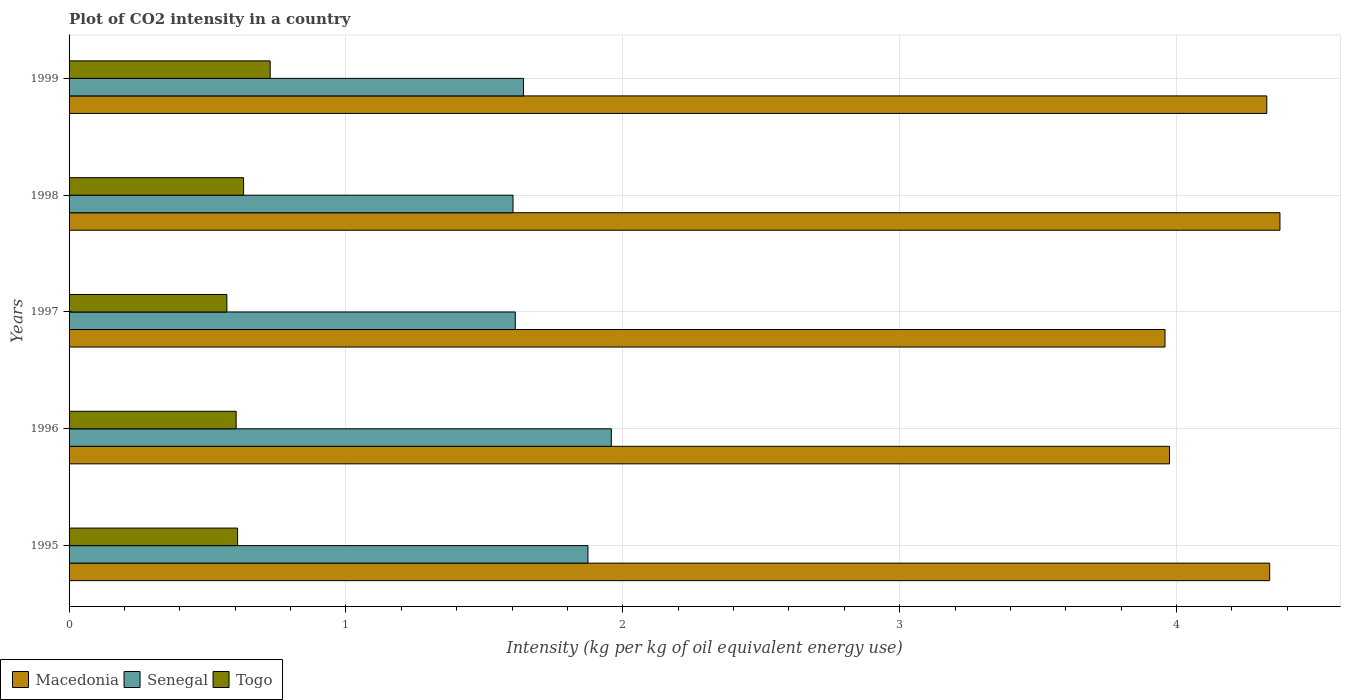How many different coloured bars are there?
Provide a succinct answer. 3. How many groups of bars are there?
Offer a terse response. 5. Are the number of bars per tick equal to the number of legend labels?
Your answer should be very brief. Yes. What is the CO2 intensity in in Senegal in 1998?
Your answer should be compact. 1.6. Across all years, what is the maximum CO2 intensity in in Togo?
Provide a short and direct response. 0.73. Across all years, what is the minimum CO2 intensity in in Togo?
Provide a succinct answer. 0.57. What is the total CO2 intensity in in Macedonia in the graph?
Your response must be concise. 20.97. What is the difference between the CO2 intensity in in Senegal in 1995 and that in 1999?
Your answer should be very brief. 0.23. What is the difference between the CO2 intensity in in Macedonia in 1997 and the CO2 intensity in in Togo in 1999?
Your response must be concise. 3.23. What is the average CO2 intensity in in Senegal per year?
Your answer should be very brief. 1.74. In the year 1996, what is the difference between the CO2 intensity in in Macedonia and CO2 intensity in in Senegal?
Your response must be concise. 2.02. What is the ratio of the CO2 intensity in in Senegal in 1995 to that in 1996?
Keep it short and to the point. 0.96. Is the difference between the CO2 intensity in in Macedonia in 1997 and 1999 greater than the difference between the CO2 intensity in in Senegal in 1997 and 1999?
Your response must be concise. No. What is the difference between the highest and the second highest CO2 intensity in in Macedonia?
Give a very brief answer. 0.04. What is the difference between the highest and the lowest CO2 intensity in in Togo?
Your response must be concise. 0.16. What does the 1st bar from the top in 1996 represents?
Ensure brevity in your answer.  Togo. What does the 1st bar from the bottom in 1998 represents?
Keep it short and to the point. Macedonia. Is it the case that in every year, the sum of the CO2 intensity in in Senegal and CO2 intensity in in Togo is greater than the CO2 intensity in in Macedonia?
Give a very brief answer. No. How many bars are there?
Your response must be concise. 15. Are all the bars in the graph horizontal?
Provide a short and direct response. Yes. Does the graph contain grids?
Ensure brevity in your answer.  Yes. Where does the legend appear in the graph?
Offer a terse response. Bottom left. How are the legend labels stacked?
Your answer should be very brief. Horizontal. What is the title of the graph?
Offer a terse response. Plot of CO2 intensity in a country. Does "Jordan" appear as one of the legend labels in the graph?
Provide a succinct answer. No. What is the label or title of the X-axis?
Offer a very short reply. Intensity (kg per kg of oil equivalent energy use). What is the label or title of the Y-axis?
Your response must be concise. Years. What is the Intensity (kg per kg of oil equivalent energy use) of Macedonia in 1995?
Offer a very short reply. 4.34. What is the Intensity (kg per kg of oil equivalent energy use) in Senegal in 1995?
Provide a short and direct response. 1.87. What is the Intensity (kg per kg of oil equivalent energy use) in Togo in 1995?
Offer a terse response. 0.61. What is the Intensity (kg per kg of oil equivalent energy use) in Macedonia in 1996?
Provide a short and direct response. 3.97. What is the Intensity (kg per kg of oil equivalent energy use) in Senegal in 1996?
Ensure brevity in your answer.  1.96. What is the Intensity (kg per kg of oil equivalent energy use) of Togo in 1996?
Your answer should be compact. 0.6. What is the Intensity (kg per kg of oil equivalent energy use) of Macedonia in 1997?
Provide a succinct answer. 3.96. What is the Intensity (kg per kg of oil equivalent energy use) in Senegal in 1997?
Your response must be concise. 1.61. What is the Intensity (kg per kg of oil equivalent energy use) in Togo in 1997?
Provide a short and direct response. 0.57. What is the Intensity (kg per kg of oil equivalent energy use) of Macedonia in 1998?
Your answer should be compact. 4.37. What is the Intensity (kg per kg of oil equivalent energy use) in Senegal in 1998?
Provide a succinct answer. 1.6. What is the Intensity (kg per kg of oil equivalent energy use) of Togo in 1998?
Offer a terse response. 0.63. What is the Intensity (kg per kg of oil equivalent energy use) of Macedonia in 1999?
Provide a short and direct response. 4.33. What is the Intensity (kg per kg of oil equivalent energy use) of Senegal in 1999?
Your answer should be compact. 1.64. What is the Intensity (kg per kg of oil equivalent energy use) in Togo in 1999?
Your answer should be very brief. 0.73. Across all years, what is the maximum Intensity (kg per kg of oil equivalent energy use) of Macedonia?
Make the answer very short. 4.37. Across all years, what is the maximum Intensity (kg per kg of oil equivalent energy use) in Senegal?
Your answer should be very brief. 1.96. Across all years, what is the maximum Intensity (kg per kg of oil equivalent energy use) of Togo?
Make the answer very short. 0.73. Across all years, what is the minimum Intensity (kg per kg of oil equivalent energy use) of Macedonia?
Provide a short and direct response. 3.96. Across all years, what is the minimum Intensity (kg per kg of oil equivalent energy use) of Senegal?
Your answer should be very brief. 1.6. Across all years, what is the minimum Intensity (kg per kg of oil equivalent energy use) of Togo?
Provide a short and direct response. 0.57. What is the total Intensity (kg per kg of oil equivalent energy use) in Macedonia in the graph?
Provide a short and direct response. 20.97. What is the total Intensity (kg per kg of oil equivalent energy use) in Senegal in the graph?
Provide a succinct answer. 8.69. What is the total Intensity (kg per kg of oil equivalent energy use) of Togo in the graph?
Ensure brevity in your answer.  3.14. What is the difference between the Intensity (kg per kg of oil equivalent energy use) of Macedonia in 1995 and that in 1996?
Provide a succinct answer. 0.36. What is the difference between the Intensity (kg per kg of oil equivalent energy use) in Senegal in 1995 and that in 1996?
Provide a short and direct response. -0.08. What is the difference between the Intensity (kg per kg of oil equivalent energy use) in Togo in 1995 and that in 1996?
Your answer should be compact. 0.01. What is the difference between the Intensity (kg per kg of oil equivalent energy use) of Macedonia in 1995 and that in 1997?
Offer a terse response. 0.38. What is the difference between the Intensity (kg per kg of oil equivalent energy use) of Senegal in 1995 and that in 1997?
Keep it short and to the point. 0.26. What is the difference between the Intensity (kg per kg of oil equivalent energy use) of Togo in 1995 and that in 1997?
Your answer should be very brief. 0.04. What is the difference between the Intensity (kg per kg of oil equivalent energy use) in Macedonia in 1995 and that in 1998?
Provide a succinct answer. -0.04. What is the difference between the Intensity (kg per kg of oil equivalent energy use) of Senegal in 1995 and that in 1998?
Your response must be concise. 0.27. What is the difference between the Intensity (kg per kg of oil equivalent energy use) of Togo in 1995 and that in 1998?
Provide a short and direct response. -0.02. What is the difference between the Intensity (kg per kg of oil equivalent energy use) of Macedonia in 1995 and that in 1999?
Your response must be concise. 0.01. What is the difference between the Intensity (kg per kg of oil equivalent energy use) of Senegal in 1995 and that in 1999?
Keep it short and to the point. 0.23. What is the difference between the Intensity (kg per kg of oil equivalent energy use) of Togo in 1995 and that in 1999?
Offer a very short reply. -0.12. What is the difference between the Intensity (kg per kg of oil equivalent energy use) of Macedonia in 1996 and that in 1997?
Your answer should be compact. 0.02. What is the difference between the Intensity (kg per kg of oil equivalent energy use) in Senegal in 1996 and that in 1997?
Your answer should be compact. 0.35. What is the difference between the Intensity (kg per kg of oil equivalent energy use) in Togo in 1996 and that in 1997?
Keep it short and to the point. 0.03. What is the difference between the Intensity (kg per kg of oil equivalent energy use) in Macedonia in 1996 and that in 1998?
Provide a succinct answer. -0.4. What is the difference between the Intensity (kg per kg of oil equivalent energy use) in Senegal in 1996 and that in 1998?
Ensure brevity in your answer.  0.35. What is the difference between the Intensity (kg per kg of oil equivalent energy use) of Togo in 1996 and that in 1998?
Ensure brevity in your answer.  -0.03. What is the difference between the Intensity (kg per kg of oil equivalent energy use) of Macedonia in 1996 and that in 1999?
Provide a succinct answer. -0.35. What is the difference between the Intensity (kg per kg of oil equivalent energy use) of Senegal in 1996 and that in 1999?
Your answer should be compact. 0.32. What is the difference between the Intensity (kg per kg of oil equivalent energy use) of Togo in 1996 and that in 1999?
Provide a succinct answer. -0.12. What is the difference between the Intensity (kg per kg of oil equivalent energy use) in Macedonia in 1997 and that in 1998?
Ensure brevity in your answer.  -0.42. What is the difference between the Intensity (kg per kg of oil equivalent energy use) in Senegal in 1997 and that in 1998?
Make the answer very short. 0.01. What is the difference between the Intensity (kg per kg of oil equivalent energy use) in Togo in 1997 and that in 1998?
Provide a short and direct response. -0.06. What is the difference between the Intensity (kg per kg of oil equivalent energy use) of Macedonia in 1997 and that in 1999?
Keep it short and to the point. -0.37. What is the difference between the Intensity (kg per kg of oil equivalent energy use) in Senegal in 1997 and that in 1999?
Your response must be concise. -0.03. What is the difference between the Intensity (kg per kg of oil equivalent energy use) in Togo in 1997 and that in 1999?
Ensure brevity in your answer.  -0.16. What is the difference between the Intensity (kg per kg of oil equivalent energy use) of Macedonia in 1998 and that in 1999?
Your answer should be very brief. 0.05. What is the difference between the Intensity (kg per kg of oil equivalent energy use) in Senegal in 1998 and that in 1999?
Keep it short and to the point. -0.04. What is the difference between the Intensity (kg per kg of oil equivalent energy use) of Togo in 1998 and that in 1999?
Offer a terse response. -0.1. What is the difference between the Intensity (kg per kg of oil equivalent energy use) of Macedonia in 1995 and the Intensity (kg per kg of oil equivalent energy use) of Senegal in 1996?
Offer a terse response. 2.38. What is the difference between the Intensity (kg per kg of oil equivalent energy use) of Macedonia in 1995 and the Intensity (kg per kg of oil equivalent energy use) of Togo in 1996?
Provide a short and direct response. 3.73. What is the difference between the Intensity (kg per kg of oil equivalent energy use) of Senegal in 1995 and the Intensity (kg per kg of oil equivalent energy use) of Togo in 1996?
Give a very brief answer. 1.27. What is the difference between the Intensity (kg per kg of oil equivalent energy use) of Macedonia in 1995 and the Intensity (kg per kg of oil equivalent energy use) of Senegal in 1997?
Ensure brevity in your answer.  2.72. What is the difference between the Intensity (kg per kg of oil equivalent energy use) of Macedonia in 1995 and the Intensity (kg per kg of oil equivalent energy use) of Togo in 1997?
Provide a succinct answer. 3.77. What is the difference between the Intensity (kg per kg of oil equivalent energy use) in Senegal in 1995 and the Intensity (kg per kg of oil equivalent energy use) in Togo in 1997?
Offer a very short reply. 1.3. What is the difference between the Intensity (kg per kg of oil equivalent energy use) of Macedonia in 1995 and the Intensity (kg per kg of oil equivalent energy use) of Senegal in 1998?
Offer a terse response. 2.73. What is the difference between the Intensity (kg per kg of oil equivalent energy use) of Macedonia in 1995 and the Intensity (kg per kg of oil equivalent energy use) of Togo in 1998?
Provide a succinct answer. 3.71. What is the difference between the Intensity (kg per kg of oil equivalent energy use) in Senegal in 1995 and the Intensity (kg per kg of oil equivalent energy use) in Togo in 1998?
Offer a terse response. 1.24. What is the difference between the Intensity (kg per kg of oil equivalent energy use) of Macedonia in 1995 and the Intensity (kg per kg of oil equivalent energy use) of Senegal in 1999?
Make the answer very short. 2.69. What is the difference between the Intensity (kg per kg of oil equivalent energy use) of Macedonia in 1995 and the Intensity (kg per kg of oil equivalent energy use) of Togo in 1999?
Your answer should be compact. 3.61. What is the difference between the Intensity (kg per kg of oil equivalent energy use) of Senegal in 1995 and the Intensity (kg per kg of oil equivalent energy use) of Togo in 1999?
Offer a terse response. 1.15. What is the difference between the Intensity (kg per kg of oil equivalent energy use) of Macedonia in 1996 and the Intensity (kg per kg of oil equivalent energy use) of Senegal in 1997?
Provide a short and direct response. 2.36. What is the difference between the Intensity (kg per kg of oil equivalent energy use) of Macedonia in 1996 and the Intensity (kg per kg of oil equivalent energy use) of Togo in 1997?
Provide a short and direct response. 3.4. What is the difference between the Intensity (kg per kg of oil equivalent energy use) in Senegal in 1996 and the Intensity (kg per kg of oil equivalent energy use) in Togo in 1997?
Make the answer very short. 1.39. What is the difference between the Intensity (kg per kg of oil equivalent energy use) of Macedonia in 1996 and the Intensity (kg per kg of oil equivalent energy use) of Senegal in 1998?
Provide a succinct answer. 2.37. What is the difference between the Intensity (kg per kg of oil equivalent energy use) in Macedonia in 1996 and the Intensity (kg per kg of oil equivalent energy use) in Togo in 1998?
Keep it short and to the point. 3.34. What is the difference between the Intensity (kg per kg of oil equivalent energy use) in Senegal in 1996 and the Intensity (kg per kg of oil equivalent energy use) in Togo in 1998?
Give a very brief answer. 1.33. What is the difference between the Intensity (kg per kg of oil equivalent energy use) in Macedonia in 1996 and the Intensity (kg per kg of oil equivalent energy use) in Senegal in 1999?
Offer a terse response. 2.33. What is the difference between the Intensity (kg per kg of oil equivalent energy use) of Macedonia in 1996 and the Intensity (kg per kg of oil equivalent energy use) of Togo in 1999?
Provide a short and direct response. 3.25. What is the difference between the Intensity (kg per kg of oil equivalent energy use) in Senegal in 1996 and the Intensity (kg per kg of oil equivalent energy use) in Togo in 1999?
Keep it short and to the point. 1.23. What is the difference between the Intensity (kg per kg of oil equivalent energy use) in Macedonia in 1997 and the Intensity (kg per kg of oil equivalent energy use) in Senegal in 1998?
Make the answer very short. 2.35. What is the difference between the Intensity (kg per kg of oil equivalent energy use) in Macedonia in 1997 and the Intensity (kg per kg of oil equivalent energy use) in Togo in 1998?
Your answer should be compact. 3.33. What is the difference between the Intensity (kg per kg of oil equivalent energy use) in Senegal in 1997 and the Intensity (kg per kg of oil equivalent energy use) in Togo in 1998?
Provide a succinct answer. 0.98. What is the difference between the Intensity (kg per kg of oil equivalent energy use) in Macedonia in 1997 and the Intensity (kg per kg of oil equivalent energy use) in Senegal in 1999?
Offer a very short reply. 2.32. What is the difference between the Intensity (kg per kg of oil equivalent energy use) of Macedonia in 1997 and the Intensity (kg per kg of oil equivalent energy use) of Togo in 1999?
Your answer should be very brief. 3.23. What is the difference between the Intensity (kg per kg of oil equivalent energy use) in Senegal in 1997 and the Intensity (kg per kg of oil equivalent energy use) in Togo in 1999?
Keep it short and to the point. 0.89. What is the difference between the Intensity (kg per kg of oil equivalent energy use) of Macedonia in 1998 and the Intensity (kg per kg of oil equivalent energy use) of Senegal in 1999?
Your response must be concise. 2.73. What is the difference between the Intensity (kg per kg of oil equivalent energy use) in Macedonia in 1998 and the Intensity (kg per kg of oil equivalent energy use) in Togo in 1999?
Offer a terse response. 3.65. What is the difference between the Intensity (kg per kg of oil equivalent energy use) of Senegal in 1998 and the Intensity (kg per kg of oil equivalent energy use) of Togo in 1999?
Make the answer very short. 0.88. What is the average Intensity (kg per kg of oil equivalent energy use) of Macedonia per year?
Provide a succinct answer. 4.19. What is the average Intensity (kg per kg of oil equivalent energy use) in Senegal per year?
Your response must be concise. 1.74. What is the average Intensity (kg per kg of oil equivalent energy use) in Togo per year?
Make the answer very short. 0.63. In the year 1995, what is the difference between the Intensity (kg per kg of oil equivalent energy use) of Macedonia and Intensity (kg per kg of oil equivalent energy use) of Senegal?
Offer a very short reply. 2.46. In the year 1995, what is the difference between the Intensity (kg per kg of oil equivalent energy use) in Macedonia and Intensity (kg per kg of oil equivalent energy use) in Togo?
Your answer should be very brief. 3.73. In the year 1995, what is the difference between the Intensity (kg per kg of oil equivalent energy use) of Senegal and Intensity (kg per kg of oil equivalent energy use) of Togo?
Provide a short and direct response. 1.27. In the year 1996, what is the difference between the Intensity (kg per kg of oil equivalent energy use) of Macedonia and Intensity (kg per kg of oil equivalent energy use) of Senegal?
Provide a short and direct response. 2.02. In the year 1996, what is the difference between the Intensity (kg per kg of oil equivalent energy use) in Macedonia and Intensity (kg per kg of oil equivalent energy use) in Togo?
Offer a terse response. 3.37. In the year 1996, what is the difference between the Intensity (kg per kg of oil equivalent energy use) in Senegal and Intensity (kg per kg of oil equivalent energy use) in Togo?
Keep it short and to the point. 1.35. In the year 1997, what is the difference between the Intensity (kg per kg of oil equivalent energy use) in Macedonia and Intensity (kg per kg of oil equivalent energy use) in Senegal?
Your answer should be compact. 2.35. In the year 1997, what is the difference between the Intensity (kg per kg of oil equivalent energy use) of Macedonia and Intensity (kg per kg of oil equivalent energy use) of Togo?
Offer a very short reply. 3.39. In the year 1997, what is the difference between the Intensity (kg per kg of oil equivalent energy use) in Senegal and Intensity (kg per kg of oil equivalent energy use) in Togo?
Your answer should be compact. 1.04. In the year 1998, what is the difference between the Intensity (kg per kg of oil equivalent energy use) in Macedonia and Intensity (kg per kg of oil equivalent energy use) in Senegal?
Keep it short and to the point. 2.77. In the year 1998, what is the difference between the Intensity (kg per kg of oil equivalent energy use) of Macedonia and Intensity (kg per kg of oil equivalent energy use) of Togo?
Provide a succinct answer. 3.74. In the year 1998, what is the difference between the Intensity (kg per kg of oil equivalent energy use) in Senegal and Intensity (kg per kg of oil equivalent energy use) in Togo?
Your answer should be compact. 0.97. In the year 1999, what is the difference between the Intensity (kg per kg of oil equivalent energy use) of Macedonia and Intensity (kg per kg of oil equivalent energy use) of Senegal?
Your response must be concise. 2.68. In the year 1999, what is the difference between the Intensity (kg per kg of oil equivalent energy use) in Macedonia and Intensity (kg per kg of oil equivalent energy use) in Togo?
Provide a short and direct response. 3.6. In the year 1999, what is the difference between the Intensity (kg per kg of oil equivalent energy use) in Senegal and Intensity (kg per kg of oil equivalent energy use) in Togo?
Offer a very short reply. 0.91. What is the ratio of the Intensity (kg per kg of oil equivalent energy use) in Macedonia in 1995 to that in 1996?
Offer a terse response. 1.09. What is the ratio of the Intensity (kg per kg of oil equivalent energy use) in Senegal in 1995 to that in 1996?
Offer a terse response. 0.96. What is the ratio of the Intensity (kg per kg of oil equivalent energy use) in Togo in 1995 to that in 1996?
Provide a succinct answer. 1.01. What is the ratio of the Intensity (kg per kg of oil equivalent energy use) in Macedonia in 1995 to that in 1997?
Provide a short and direct response. 1.1. What is the ratio of the Intensity (kg per kg of oil equivalent energy use) of Senegal in 1995 to that in 1997?
Ensure brevity in your answer.  1.16. What is the ratio of the Intensity (kg per kg of oil equivalent energy use) of Togo in 1995 to that in 1997?
Provide a short and direct response. 1.07. What is the ratio of the Intensity (kg per kg of oil equivalent energy use) of Senegal in 1995 to that in 1998?
Make the answer very short. 1.17. What is the ratio of the Intensity (kg per kg of oil equivalent energy use) in Togo in 1995 to that in 1998?
Your answer should be very brief. 0.97. What is the ratio of the Intensity (kg per kg of oil equivalent energy use) in Senegal in 1995 to that in 1999?
Your response must be concise. 1.14. What is the ratio of the Intensity (kg per kg of oil equivalent energy use) of Togo in 1995 to that in 1999?
Keep it short and to the point. 0.84. What is the ratio of the Intensity (kg per kg of oil equivalent energy use) in Senegal in 1996 to that in 1997?
Your answer should be compact. 1.22. What is the ratio of the Intensity (kg per kg of oil equivalent energy use) of Togo in 1996 to that in 1997?
Give a very brief answer. 1.06. What is the ratio of the Intensity (kg per kg of oil equivalent energy use) of Macedonia in 1996 to that in 1998?
Your answer should be compact. 0.91. What is the ratio of the Intensity (kg per kg of oil equivalent energy use) of Senegal in 1996 to that in 1998?
Make the answer very short. 1.22. What is the ratio of the Intensity (kg per kg of oil equivalent energy use) in Togo in 1996 to that in 1998?
Offer a terse response. 0.96. What is the ratio of the Intensity (kg per kg of oil equivalent energy use) of Macedonia in 1996 to that in 1999?
Offer a terse response. 0.92. What is the ratio of the Intensity (kg per kg of oil equivalent energy use) in Senegal in 1996 to that in 1999?
Provide a succinct answer. 1.19. What is the ratio of the Intensity (kg per kg of oil equivalent energy use) in Togo in 1996 to that in 1999?
Keep it short and to the point. 0.83. What is the ratio of the Intensity (kg per kg of oil equivalent energy use) in Macedonia in 1997 to that in 1998?
Offer a very short reply. 0.91. What is the ratio of the Intensity (kg per kg of oil equivalent energy use) in Senegal in 1997 to that in 1998?
Provide a succinct answer. 1.01. What is the ratio of the Intensity (kg per kg of oil equivalent energy use) of Togo in 1997 to that in 1998?
Your response must be concise. 0.9. What is the ratio of the Intensity (kg per kg of oil equivalent energy use) of Macedonia in 1997 to that in 1999?
Ensure brevity in your answer.  0.92. What is the ratio of the Intensity (kg per kg of oil equivalent energy use) in Senegal in 1997 to that in 1999?
Offer a terse response. 0.98. What is the ratio of the Intensity (kg per kg of oil equivalent energy use) in Togo in 1997 to that in 1999?
Make the answer very short. 0.78. What is the ratio of the Intensity (kg per kg of oil equivalent energy use) in Senegal in 1998 to that in 1999?
Offer a very short reply. 0.98. What is the ratio of the Intensity (kg per kg of oil equivalent energy use) of Togo in 1998 to that in 1999?
Your response must be concise. 0.87. What is the difference between the highest and the second highest Intensity (kg per kg of oil equivalent energy use) in Macedonia?
Give a very brief answer. 0.04. What is the difference between the highest and the second highest Intensity (kg per kg of oil equivalent energy use) in Senegal?
Offer a terse response. 0.08. What is the difference between the highest and the second highest Intensity (kg per kg of oil equivalent energy use) of Togo?
Offer a very short reply. 0.1. What is the difference between the highest and the lowest Intensity (kg per kg of oil equivalent energy use) of Macedonia?
Give a very brief answer. 0.42. What is the difference between the highest and the lowest Intensity (kg per kg of oil equivalent energy use) in Senegal?
Give a very brief answer. 0.35. What is the difference between the highest and the lowest Intensity (kg per kg of oil equivalent energy use) of Togo?
Provide a short and direct response. 0.16. 